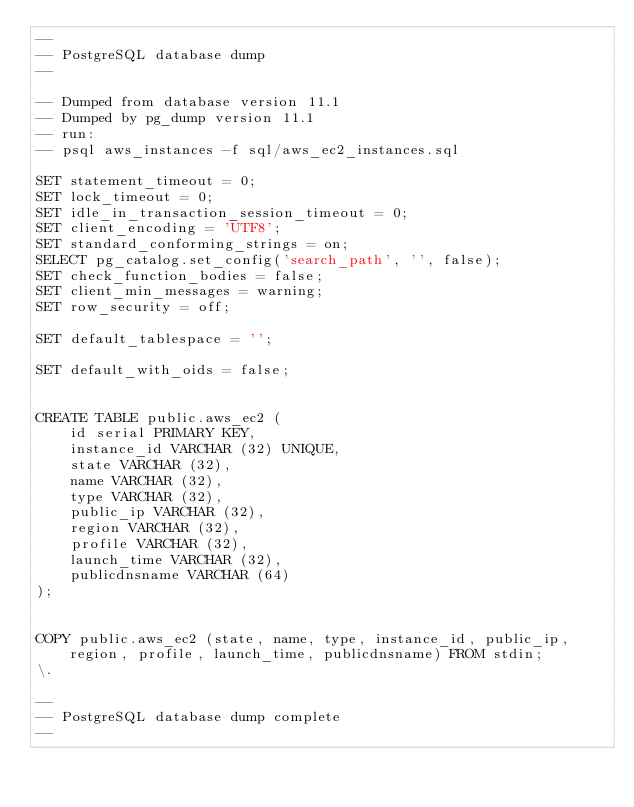<code> <loc_0><loc_0><loc_500><loc_500><_SQL_>--
-- PostgreSQL database dump
--

-- Dumped from database version 11.1
-- Dumped by pg_dump version 11.1
-- run:
-- psql aws_instances -f sql/aws_ec2_instances.sql

SET statement_timeout = 0;
SET lock_timeout = 0;
SET idle_in_transaction_session_timeout = 0;
SET client_encoding = 'UTF8';
SET standard_conforming_strings = on;
SELECT pg_catalog.set_config('search_path', '', false);
SET check_function_bodies = false;
SET client_min_messages = warning;
SET row_security = off;

SET default_tablespace = '';

SET default_with_oids = false;


CREATE TABLE public.aws_ec2 (
    id serial PRIMARY KEY,
    instance_id VARCHAR (32) UNIQUE,
    state VARCHAR (32),
    name VARCHAR (32),
    type VARCHAR (32),
    public_ip VARCHAR (32),
    region VARCHAR (32),
    profile VARCHAR (32),
    launch_time VARCHAR (32),
    publicdnsname VARCHAR (64)
);


COPY public.aws_ec2 (state, name, type, instance_id, public_ip, region, profile, launch_time, publicdnsname) FROM stdin;
\.

--
-- PostgreSQL database dump complete
--

</code> 